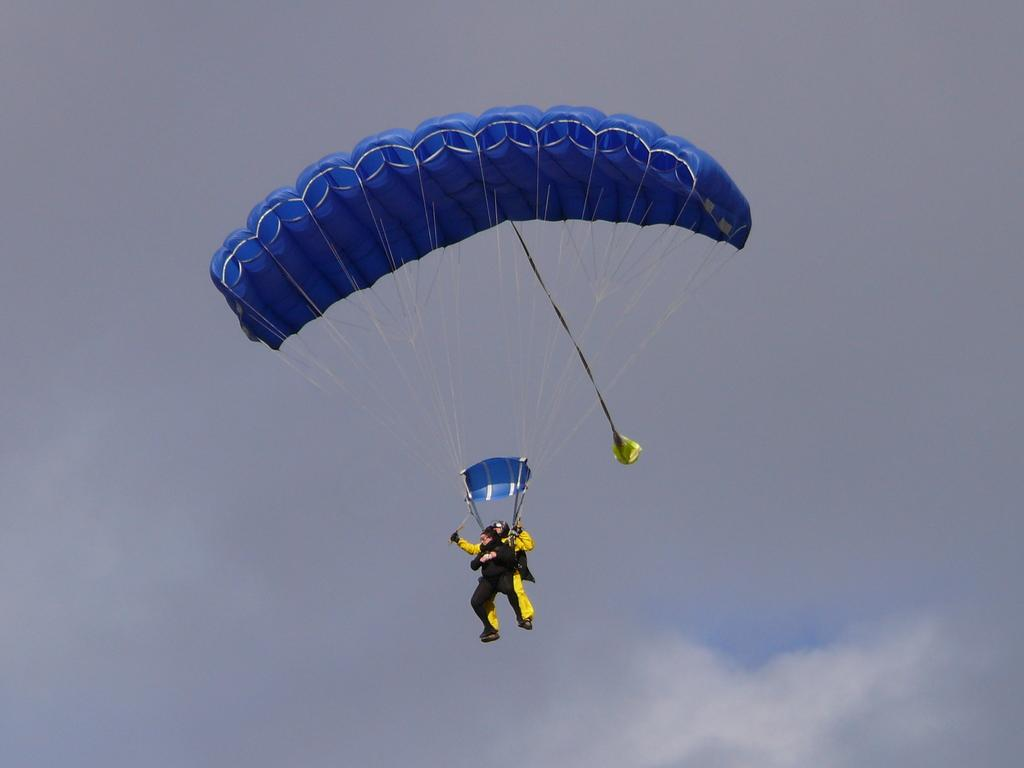What is the person in the image doing? The person is flying with the help of a parachute. What is the person using to stay in the air? The person is using a parachute to stay in the air. What can be seen in the background of the image? The sky is visible in the background of the image. What is the condition of the sky in the image? Clouds are present in the sky. What type of substance is the person holding in their hand while flying? There is no substance visible in the person's hand in the image. Can you tell me how many uncles are present in the image? There are no uncles present in the image; it features a person flying with a parachute. What type of twig can be seen in the image? There is no twig present in the image. 